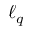<formula> <loc_0><loc_0><loc_500><loc_500>\ell _ { q }</formula> 